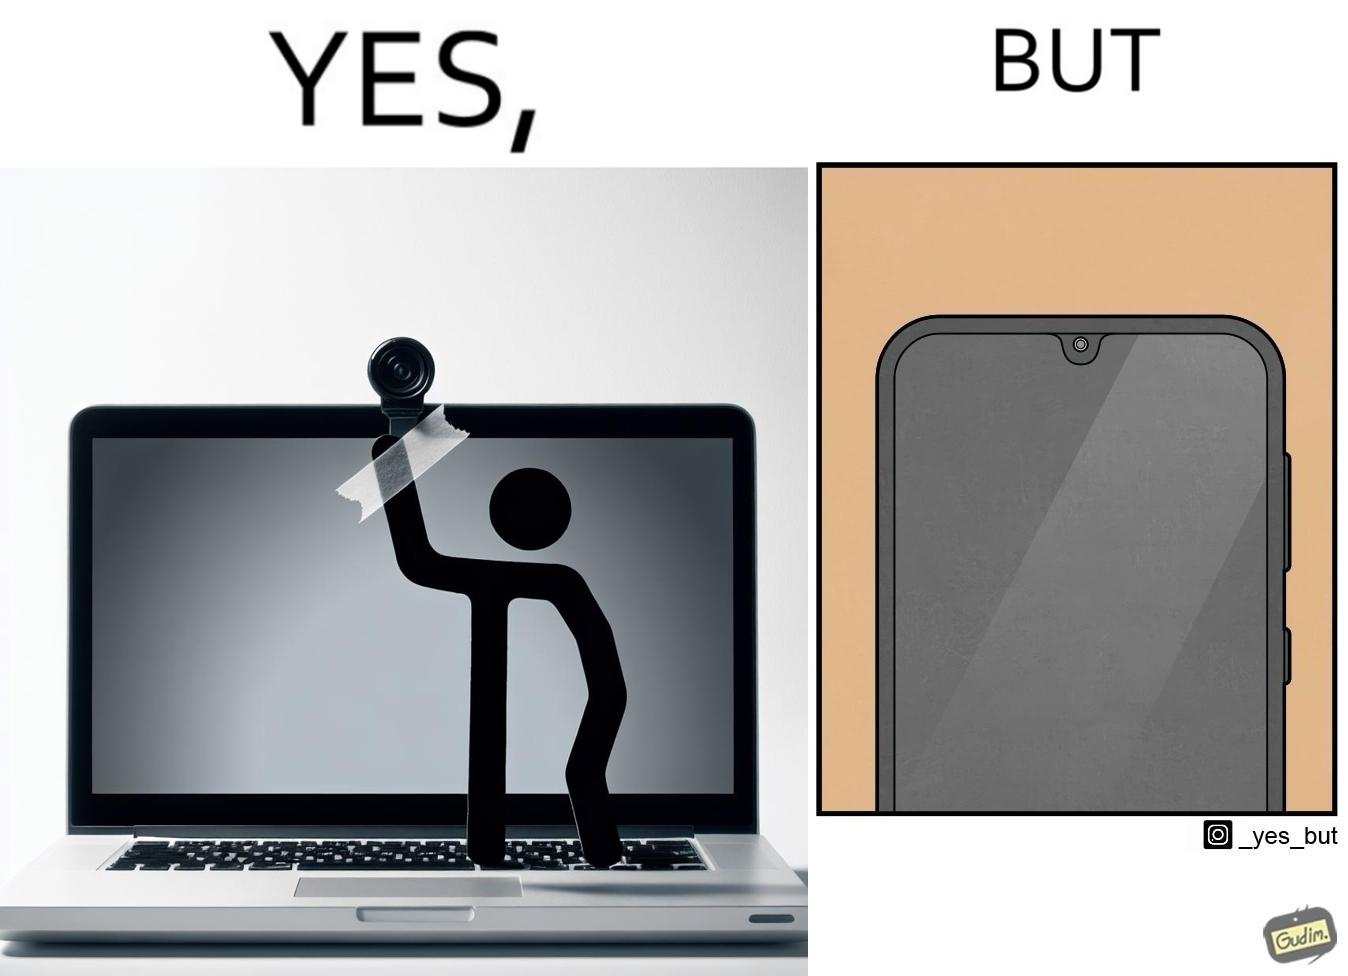What is shown in the left half versus the right half of this image? In the left part of the image: a person applying tape over a laptop's camera In the right part of the image: a smartphone screen 